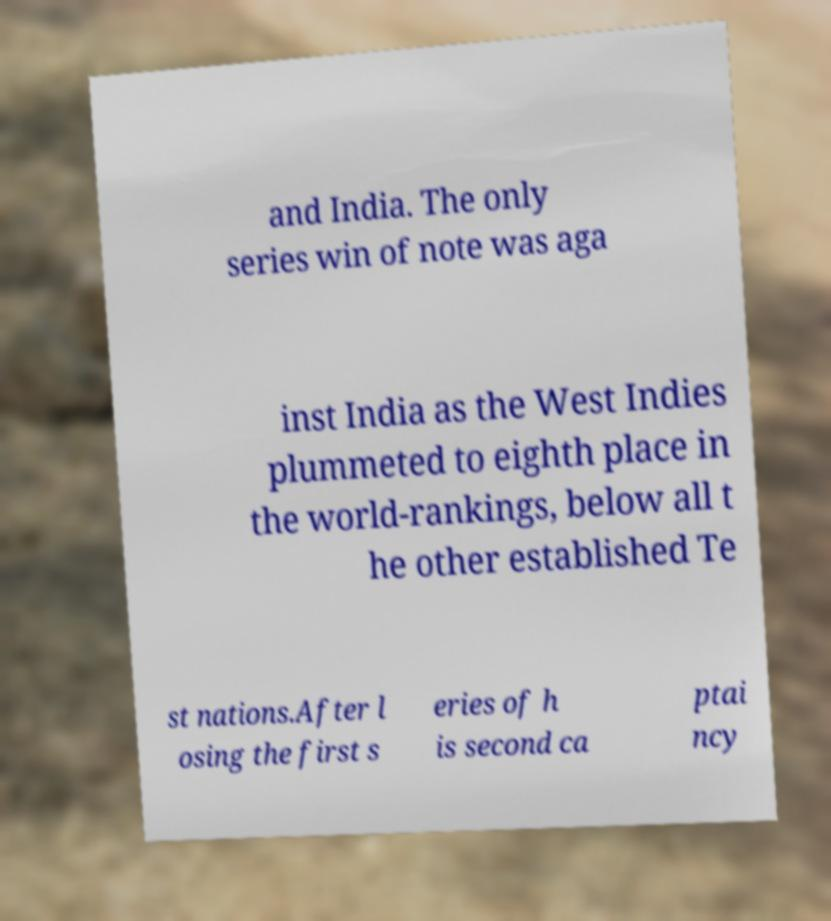Please read and relay the text visible in this image. What does it say? and India. The only series win of note was aga inst India as the West Indies plummeted to eighth place in the world-rankings, below all t he other established Te st nations.After l osing the first s eries of h is second ca ptai ncy 